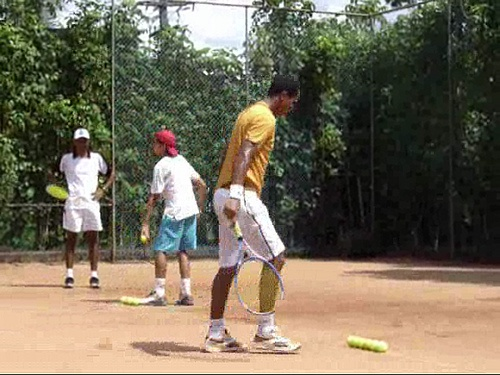Describe the objects in this image and their specific colors. I can see people in gray, darkgray, white, maroon, and olive tones, people in gray, white, and darkgray tones, people in gray, white, darkgray, black, and maroon tones, tennis racket in gray, tan, olive, and darkgray tones, and tennis racket in gray and black tones in this image. 